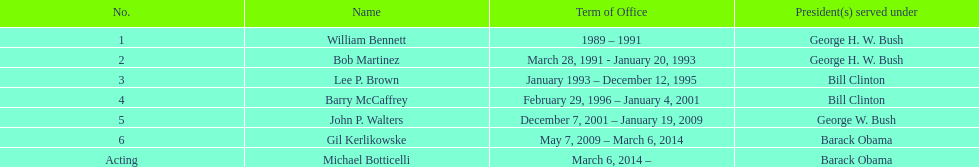How many directors served more than 3 years? 3. 